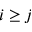Convert formula to latex. <formula><loc_0><loc_0><loc_500><loc_500>i \geq j</formula> 